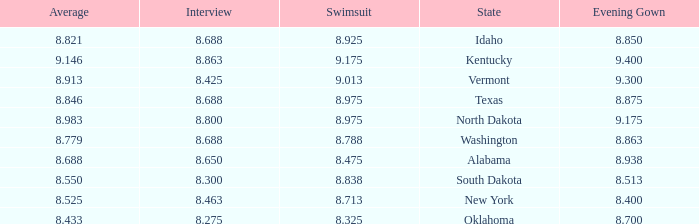What is the highest swimsuit score of the contestant with an evening gown larger than 9.175 and an interview score less than 8.425? None. 